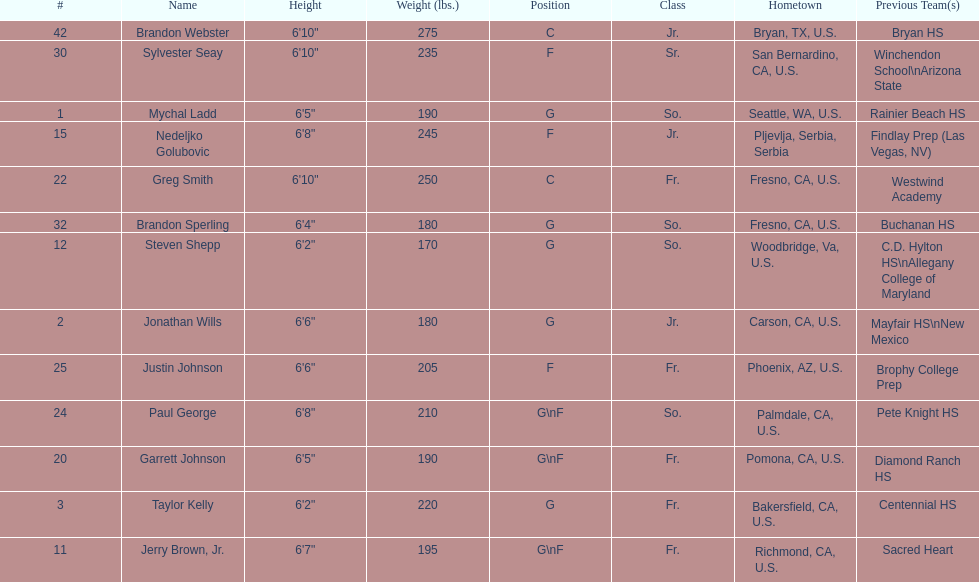Who is the only player not from the u. s.? Nedeljko Golubovic. 